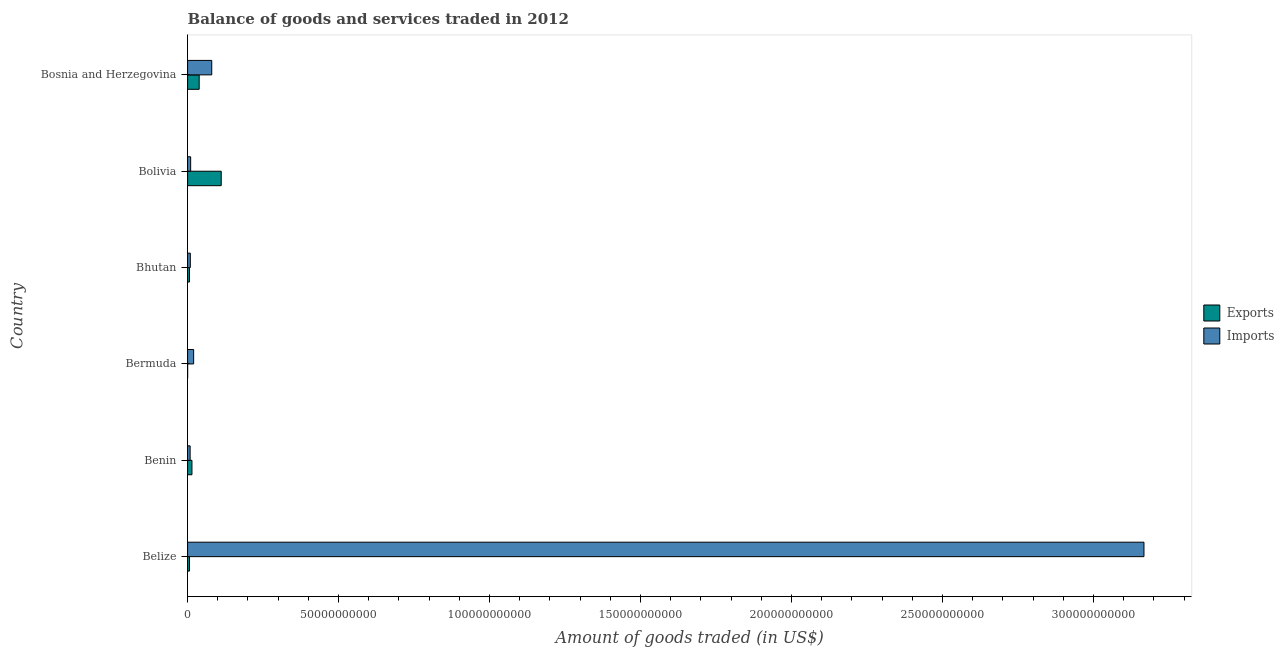How many different coloured bars are there?
Make the answer very short. 2. How many bars are there on the 1st tick from the top?
Ensure brevity in your answer.  2. What is the label of the 5th group of bars from the top?
Provide a succinct answer. Benin. In how many cases, is the number of bars for a given country not equal to the number of legend labels?
Provide a succinct answer. 0. What is the amount of goods imported in Bosnia and Herzegovina?
Provide a succinct answer. 8.00e+09. Across all countries, what is the maximum amount of goods imported?
Offer a very short reply. 3.17e+11. Across all countries, what is the minimum amount of goods exported?
Give a very brief answer. 1.11e+07. In which country was the amount of goods exported maximum?
Make the answer very short. Bolivia. In which country was the amount of goods imported minimum?
Provide a short and direct response. Benin. What is the total amount of goods imported in the graph?
Your answer should be compact. 3.29e+11. What is the difference between the amount of goods exported in Benin and that in Bhutan?
Provide a short and direct response. 8.16e+08. What is the difference between the amount of goods exported in Bosnia and Herzegovina and the amount of goods imported in Bolivia?
Ensure brevity in your answer.  2.82e+09. What is the average amount of goods exported per country?
Give a very brief answer. 2.95e+09. What is the difference between the amount of goods imported and amount of goods exported in Bermuda?
Offer a terse response. 1.99e+09. What is the ratio of the amount of goods imported in Belize to that in Benin?
Offer a very short reply. 378.43. What is the difference between the highest and the second highest amount of goods imported?
Give a very brief answer. 3.09e+11. What is the difference between the highest and the lowest amount of goods imported?
Your response must be concise. 3.16e+11. Is the sum of the amount of goods exported in Bermuda and Bosnia and Herzegovina greater than the maximum amount of goods imported across all countries?
Ensure brevity in your answer.  No. What does the 2nd bar from the top in Bermuda represents?
Offer a terse response. Exports. What does the 2nd bar from the bottom in Belize represents?
Provide a succinct answer. Imports. How many bars are there?
Your answer should be compact. 12. Are all the bars in the graph horizontal?
Offer a terse response. Yes. Are the values on the major ticks of X-axis written in scientific E-notation?
Offer a terse response. No. Where does the legend appear in the graph?
Offer a terse response. Center right. How many legend labels are there?
Your answer should be very brief. 2. What is the title of the graph?
Give a very brief answer. Balance of goods and services traded in 2012. What is the label or title of the X-axis?
Keep it short and to the point. Amount of goods traded (in US$). What is the label or title of the Y-axis?
Offer a terse response. Country. What is the Amount of goods traded (in US$) in Exports in Belize?
Give a very brief answer. 6.28e+08. What is the Amount of goods traded (in US$) of Imports in Belize?
Keep it short and to the point. 3.17e+11. What is the Amount of goods traded (in US$) of Exports in Benin?
Provide a short and direct response. 1.44e+09. What is the Amount of goods traded (in US$) in Imports in Benin?
Your response must be concise. 8.37e+08. What is the Amount of goods traded (in US$) of Exports in Bermuda?
Offer a terse response. 1.11e+07. What is the Amount of goods traded (in US$) of Imports in Bermuda?
Your answer should be very brief. 2.00e+09. What is the Amount of goods traded (in US$) of Exports in Bhutan?
Your answer should be compact. 6.27e+08. What is the Amount of goods traded (in US$) of Imports in Bhutan?
Make the answer very short. 9.00e+08. What is the Amount of goods traded (in US$) in Exports in Bolivia?
Offer a very short reply. 1.11e+1. What is the Amount of goods traded (in US$) of Imports in Bolivia?
Give a very brief answer. 1.01e+09. What is the Amount of goods traded (in US$) of Exports in Bosnia and Herzegovina?
Give a very brief answer. 3.84e+09. What is the Amount of goods traded (in US$) in Imports in Bosnia and Herzegovina?
Provide a succinct answer. 8.00e+09. Across all countries, what is the maximum Amount of goods traded (in US$) of Exports?
Keep it short and to the point. 1.11e+1. Across all countries, what is the maximum Amount of goods traded (in US$) in Imports?
Your answer should be very brief. 3.17e+11. Across all countries, what is the minimum Amount of goods traded (in US$) in Exports?
Offer a very short reply. 1.11e+07. Across all countries, what is the minimum Amount of goods traded (in US$) in Imports?
Give a very brief answer. 8.37e+08. What is the total Amount of goods traded (in US$) in Exports in the graph?
Your answer should be compact. 1.77e+1. What is the total Amount of goods traded (in US$) of Imports in the graph?
Keep it short and to the point. 3.29e+11. What is the difference between the Amount of goods traded (in US$) in Exports in Belize and that in Benin?
Your response must be concise. -8.15e+08. What is the difference between the Amount of goods traded (in US$) of Imports in Belize and that in Benin?
Your response must be concise. 3.16e+11. What is the difference between the Amount of goods traded (in US$) in Exports in Belize and that in Bermuda?
Offer a terse response. 6.17e+08. What is the difference between the Amount of goods traded (in US$) in Imports in Belize and that in Bermuda?
Keep it short and to the point. 3.15e+11. What is the difference between the Amount of goods traded (in US$) in Exports in Belize and that in Bhutan?
Ensure brevity in your answer.  9.79e+05. What is the difference between the Amount of goods traded (in US$) in Imports in Belize and that in Bhutan?
Keep it short and to the point. 3.16e+11. What is the difference between the Amount of goods traded (in US$) in Exports in Belize and that in Bolivia?
Give a very brief answer. -1.05e+1. What is the difference between the Amount of goods traded (in US$) of Imports in Belize and that in Bolivia?
Provide a succinct answer. 3.16e+11. What is the difference between the Amount of goods traded (in US$) in Exports in Belize and that in Bosnia and Herzegovina?
Give a very brief answer. -3.21e+09. What is the difference between the Amount of goods traded (in US$) of Imports in Belize and that in Bosnia and Herzegovina?
Your response must be concise. 3.09e+11. What is the difference between the Amount of goods traded (in US$) of Exports in Benin and that in Bermuda?
Ensure brevity in your answer.  1.43e+09. What is the difference between the Amount of goods traded (in US$) in Imports in Benin and that in Bermuda?
Give a very brief answer. -1.17e+09. What is the difference between the Amount of goods traded (in US$) in Exports in Benin and that in Bhutan?
Your response must be concise. 8.16e+08. What is the difference between the Amount of goods traded (in US$) in Imports in Benin and that in Bhutan?
Your answer should be very brief. -6.34e+07. What is the difference between the Amount of goods traded (in US$) of Exports in Benin and that in Bolivia?
Give a very brief answer. -9.69e+09. What is the difference between the Amount of goods traded (in US$) in Imports in Benin and that in Bolivia?
Make the answer very short. -1.75e+08. What is the difference between the Amount of goods traded (in US$) of Exports in Benin and that in Bosnia and Herzegovina?
Provide a short and direct response. -2.39e+09. What is the difference between the Amount of goods traded (in US$) in Imports in Benin and that in Bosnia and Herzegovina?
Provide a short and direct response. -7.16e+09. What is the difference between the Amount of goods traded (in US$) in Exports in Bermuda and that in Bhutan?
Your answer should be compact. -6.16e+08. What is the difference between the Amount of goods traded (in US$) in Imports in Bermuda and that in Bhutan?
Keep it short and to the point. 1.10e+09. What is the difference between the Amount of goods traded (in US$) of Exports in Bermuda and that in Bolivia?
Offer a very short reply. -1.11e+1. What is the difference between the Amount of goods traded (in US$) in Imports in Bermuda and that in Bolivia?
Make the answer very short. 9.90e+08. What is the difference between the Amount of goods traded (in US$) of Exports in Bermuda and that in Bosnia and Herzegovina?
Your answer should be very brief. -3.83e+09. What is the difference between the Amount of goods traded (in US$) in Imports in Bermuda and that in Bosnia and Herzegovina?
Provide a succinct answer. -6.00e+09. What is the difference between the Amount of goods traded (in US$) of Exports in Bhutan and that in Bolivia?
Keep it short and to the point. -1.05e+1. What is the difference between the Amount of goods traded (in US$) of Imports in Bhutan and that in Bolivia?
Make the answer very short. -1.12e+08. What is the difference between the Amount of goods traded (in US$) in Exports in Bhutan and that in Bosnia and Herzegovina?
Your answer should be very brief. -3.21e+09. What is the difference between the Amount of goods traded (in US$) in Imports in Bhutan and that in Bosnia and Herzegovina?
Give a very brief answer. -7.10e+09. What is the difference between the Amount of goods traded (in US$) in Exports in Bolivia and that in Bosnia and Herzegovina?
Provide a succinct answer. 7.30e+09. What is the difference between the Amount of goods traded (in US$) in Imports in Bolivia and that in Bosnia and Herzegovina?
Keep it short and to the point. -6.99e+09. What is the difference between the Amount of goods traded (in US$) of Exports in Belize and the Amount of goods traded (in US$) of Imports in Benin?
Provide a short and direct response. -2.09e+08. What is the difference between the Amount of goods traded (in US$) of Exports in Belize and the Amount of goods traded (in US$) of Imports in Bermuda?
Provide a short and direct response. -1.37e+09. What is the difference between the Amount of goods traded (in US$) in Exports in Belize and the Amount of goods traded (in US$) in Imports in Bhutan?
Provide a short and direct response. -2.73e+08. What is the difference between the Amount of goods traded (in US$) in Exports in Belize and the Amount of goods traded (in US$) in Imports in Bolivia?
Make the answer very short. -3.85e+08. What is the difference between the Amount of goods traded (in US$) of Exports in Belize and the Amount of goods traded (in US$) of Imports in Bosnia and Herzegovina?
Offer a terse response. -7.37e+09. What is the difference between the Amount of goods traded (in US$) in Exports in Benin and the Amount of goods traded (in US$) in Imports in Bermuda?
Ensure brevity in your answer.  -5.59e+08. What is the difference between the Amount of goods traded (in US$) of Exports in Benin and the Amount of goods traded (in US$) of Imports in Bhutan?
Give a very brief answer. 5.42e+08. What is the difference between the Amount of goods traded (in US$) of Exports in Benin and the Amount of goods traded (in US$) of Imports in Bolivia?
Provide a succinct answer. 4.30e+08. What is the difference between the Amount of goods traded (in US$) of Exports in Benin and the Amount of goods traded (in US$) of Imports in Bosnia and Herzegovina?
Your answer should be compact. -6.55e+09. What is the difference between the Amount of goods traded (in US$) of Exports in Bermuda and the Amount of goods traded (in US$) of Imports in Bhutan?
Your answer should be very brief. -8.89e+08. What is the difference between the Amount of goods traded (in US$) of Exports in Bermuda and the Amount of goods traded (in US$) of Imports in Bolivia?
Your answer should be very brief. -1.00e+09. What is the difference between the Amount of goods traded (in US$) in Exports in Bermuda and the Amount of goods traded (in US$) in Imports in Bosnia and Herzegovina?
Provide a succinct answer. -7.99e+09. What is the difference between the Amount of goods traded (in US$) of Exports in Bhutan and the Amount of goods traded (in US$) of Imports in Bolivia?
Your answer should be very brief. -3.86e+08. What is the difference between the Amount of goods traded (in US$) in Exports in Bhutan and the Amount of goods traded (in US$) in Imports in Bosnia and Herzegovina?
Keep it short and to the point. -7.37e+09. What is the difference between the Amount of goods traded (in US$) of Exports in Bolivia and the Amount of goods traded (in US$) of Imports in Bosnia and Herzegovina?
Keep it short and to the point. 3.14e+09. What is the average Amount of goods traded (in US$) in Exports per country?
Provide a succinct answer. 2.95e+09. What is the average Amount of goods traded (in US$) in Imports per country?
Give a very brief answer. 5.49e+1. What is the difference between the Amount of goods traded (in US$) in Exports and Amount of goods traded (in US$) in Imports in Belize?
Your answer should be very brief. -3.16e+11. What is the difference between the Amount of goods traded (in US$) of Exports and Amount of goods traded (in US$) of Imports in Benin?
Your answer should be very brief. 6.06e+08. What is the difference between the Amount of goods traded (in US$) in Exports and Amount of goods traded (in US$) in Imports in Bermuda?
Make the answer very short. -1.99e+09. What is the difference between the Amount of goods traded (in US$) in Exports and Amount of goods traded (in US$) in Imports in Bhutan?
Your answer should be very brief. -2.73e+08. What is the difference between the Amount of goods traded (in US$) in Exports and Amount of goods traded (in US$) in Imports in Bolivia?
Provide a succinct answer. 1.01e+1. What is the difference between the Amount of goods traded (in US$) of Exports and Amount of goods traded (in US$) of Imports in Bosnia and Herzegovina?
Ensure brevity in your answer.  -4.16e+09. What is the ratio of the Amount of goods traded (in US$) in Exports in Belize to that in Benin?
Your response must be concise. 0.44. What is the ratio of the Amount of goods traded (in US$) of Imports in Belize to that in Benin?
Provide a short and direct response. 378.43. What is the ratio of the Amount of goods traded (in US$) of Exports in Belize to that in Bermuda?
Your answer should be very brief. 56.36. What is the ratio of the Amount of goods traded (in US$) of Imports in Belize to that in Bermuda?
Make the answer very short. 158.2. What is the ratio of the Amount of goods traded (in US$) of Imports in Belize to that in Bhutan?
Ensure brevity in your answer.  351.79. What is the ratio of the Amount of goods traded (in US$) in Exports in Belize to that in Bolivia?
Offer a terse response. 0.06. What is the ratio of the Amount of goods traded (in US$) of Imports in Belize to that in Bolivia?
Your answer should be very brief. 312.85. What is the ratio of the Amount of goods traded (in US$) of Exports in Belize to that in Bosnia and Herzegovina?
Your response must be concise. 0.16. What is the ratio of the Amount of goods traded (in US$) in Imports in Belize to that in Bosnia and Herzegovina?
Offer a terse response. 39.6. What is the ratio of the Amount of goods traded (in US$) of Exports in Benin to that in Bermuda?
Give a very brief answer. 129.5. What is the ratio of the Amount of goods traded (in US$) of Imports in Benin to that in Bermuda?
Provide a succinct answer. 0.42. What is the ratio of the Amount of goods traded (in US$) in Exports in Benin to that in Bhutan?
Your answer should be very brief. 2.3. What is the ratio of the Amount of goods traded (in US$) in Imports in Benin to that in Bhutan?
Your answer should be compact. 0.93. What is the ratio of the Amount of goods traded (in US$) in Exports in Benin to that in Bolivia?
Offer a terse response. 0.13. What is the ratio of the Amount of goods traded (in US$) of Imports in Benin to that in Bolivia?
Provide a short and direct response. 0.83. What is the ratio of the Amount of goods traded (in US$) in Exports in Benin to that in Bosnia and Herzegovina?
Give a very brief answer. 0.38. What is the ratio of the Amount of goods traded (in US$) in Imports in Benin to that in Bosnia and Herzegovina?
Your answer should be very brief. 0.1. What is the ratio of the Amount of goods traded (in US$) of Exports in Bermuda to that in Bhutan?
Offer a terse response. 0.02. What is the ratio of the Amount of goods traded (in US$) of Imports in Bermuda to that in Bhutan?
Give a very brief answer. 2.22. What is the ratio of the Amount of goods traded (in US$) of Imports in Bermuda to that in Bolivia?
Keep it short and to the point. 1.98. What is the ratio of the Amount of goods traded (in US$) of Exports in Bermuda to that in Bosnia and Herzegovina?
Offer a very short reply. 0. What is the ratio of the Amount of goods traded (in US$) in Imports in Bermuda to that in Bosnia and Herzegovina?
Your response must be concise. 0.25. What is the ratio of the Amount of goods traded (in US$) of Exports in Bhutan to that in Bolivia?
Offer a terse response. 0.06. What is the ratio of the Amount of goods traded (in US$) in Imports in Bhutan to that in Bolivia?
Offer a very short reply. 0.89. What is the ratio of the Amount of goods traded (in US$) in Exports in Bhutan to that in Bosnia and Herzegovina?
Make the answer very short. 0.16. What is the ratio of the Amount of goods traded (in US$) of Imports in Bhutan to that in Bosnia and Herzegovina?
Your answer should be very brief. 0.11. What is the ratio of the Amount of goods traded (in US$) in Exports in Bolivia to that in Bosnia and Herzegovina?
Give a very brief answer. 2.9. What is the ratio of the Amount of goods traded (in US$) of Imports in Bolivia to that in Bosnia and Herzegovina?
Your answer should be compact. 0.13. What is the difference between the highest and the second highest Amount of goods traded (in US$) in Exports?
Keep it short and to the point. 7.30e+09. What is the difference between the highest and the second highest Amount of goods traded (in US$) of Imports?
Give a very brief answer. 3.09e+11. What is the difference between the highest and the lowest Amount of goods traded (in US$) in Exports?
Provide a succinct answer. 1.11e+1. What is the difference between the highest and the lowest Amount of goods traded (in US$) in Imports?
Your response must be concise. 3.16e+11. 